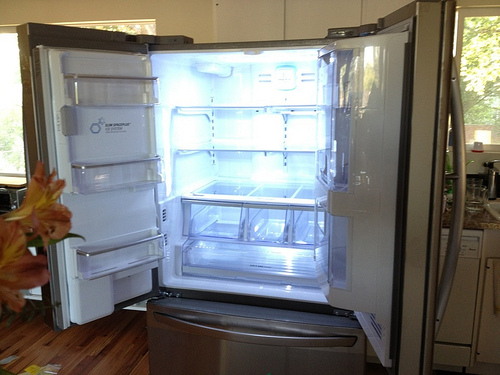Please provide a short description for this region: [0.36, 0.52, 0.65, 0.62]. The refrigerated compartment in question contains stacked, clear plastic storage boxes filled with various food items, showcasing organization within the fridge. 